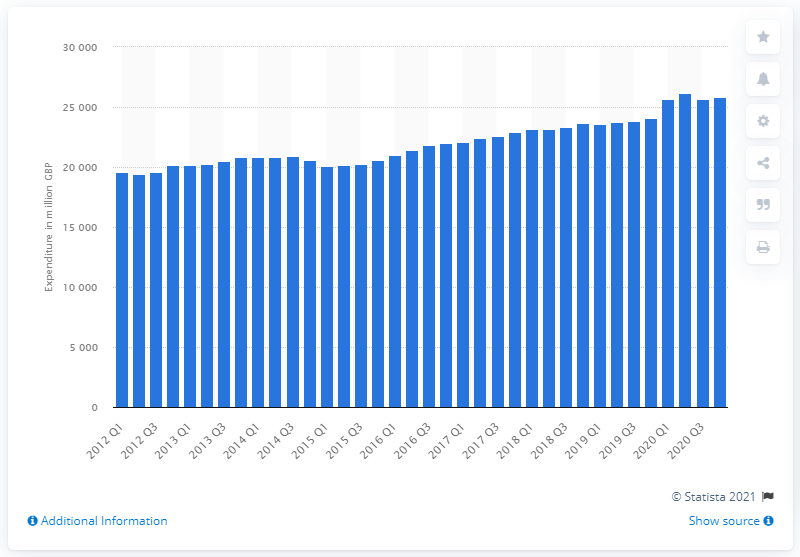Indicate a few pertinent items in this graphic. Consumer spending in the last quarter of 2020 was $25,807. 